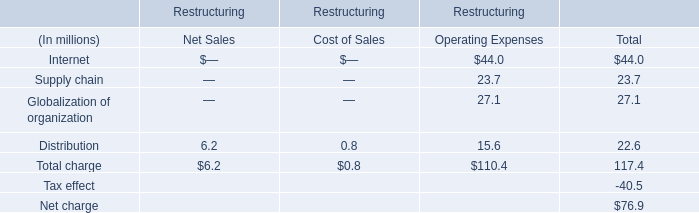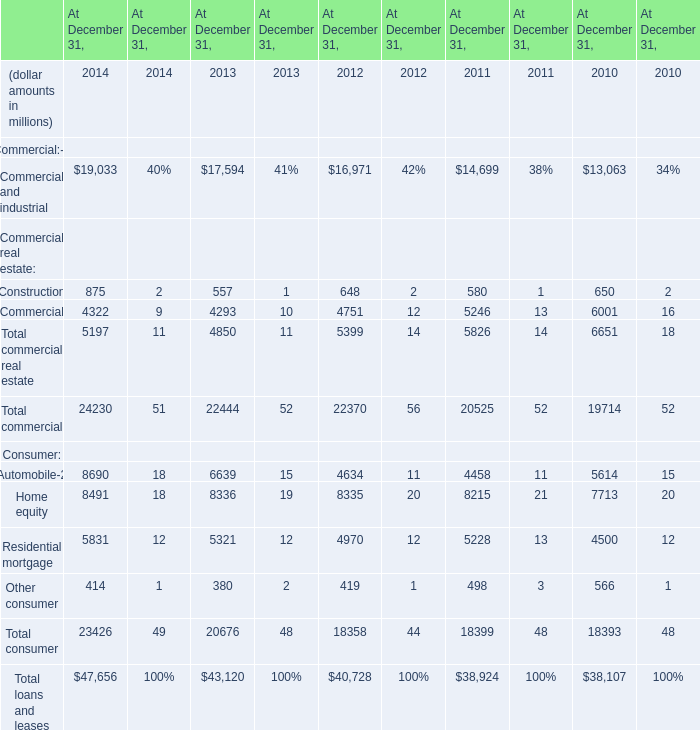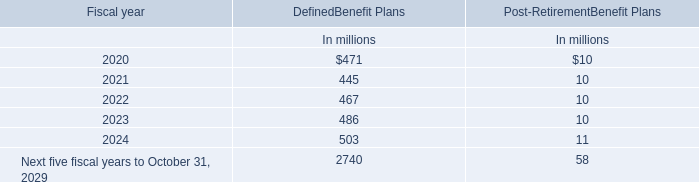What is the average value of Total commercial in 2011, 2013, and 2012? (in million) 
Computations: (((22444 + 22370) + 20525) / 3)
Answer: 21779.66667. 